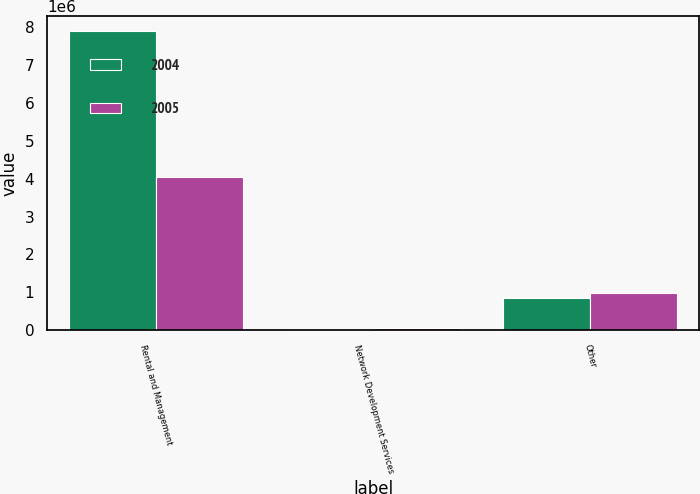<chart> <loc_0><loc_0><loc_500><loc_500><stacked_bar_chart><ecel><fcel>Rental and Management<fcel>Network Development Services<fcel>Other<nl><fcel>2004<fcel>7.88093e+06<fcel>26716<fcel>860576<nl><fcel>2005<fcel>4.0507e+06<fcel>55294<fcel>979975<nl></chart> 